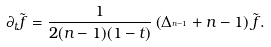Convert formula to latex. <formula><loc_0><loc_0><loc_500><loc_500>\partial _ { t } \tilde { f } = \frac { 1 } { 2 ( n - 1 ) ( 1 - t ) } \left ( \Delta _ { ^ { n - 1 } } + n - 1 \right ) \tilde { f } .</formula> 